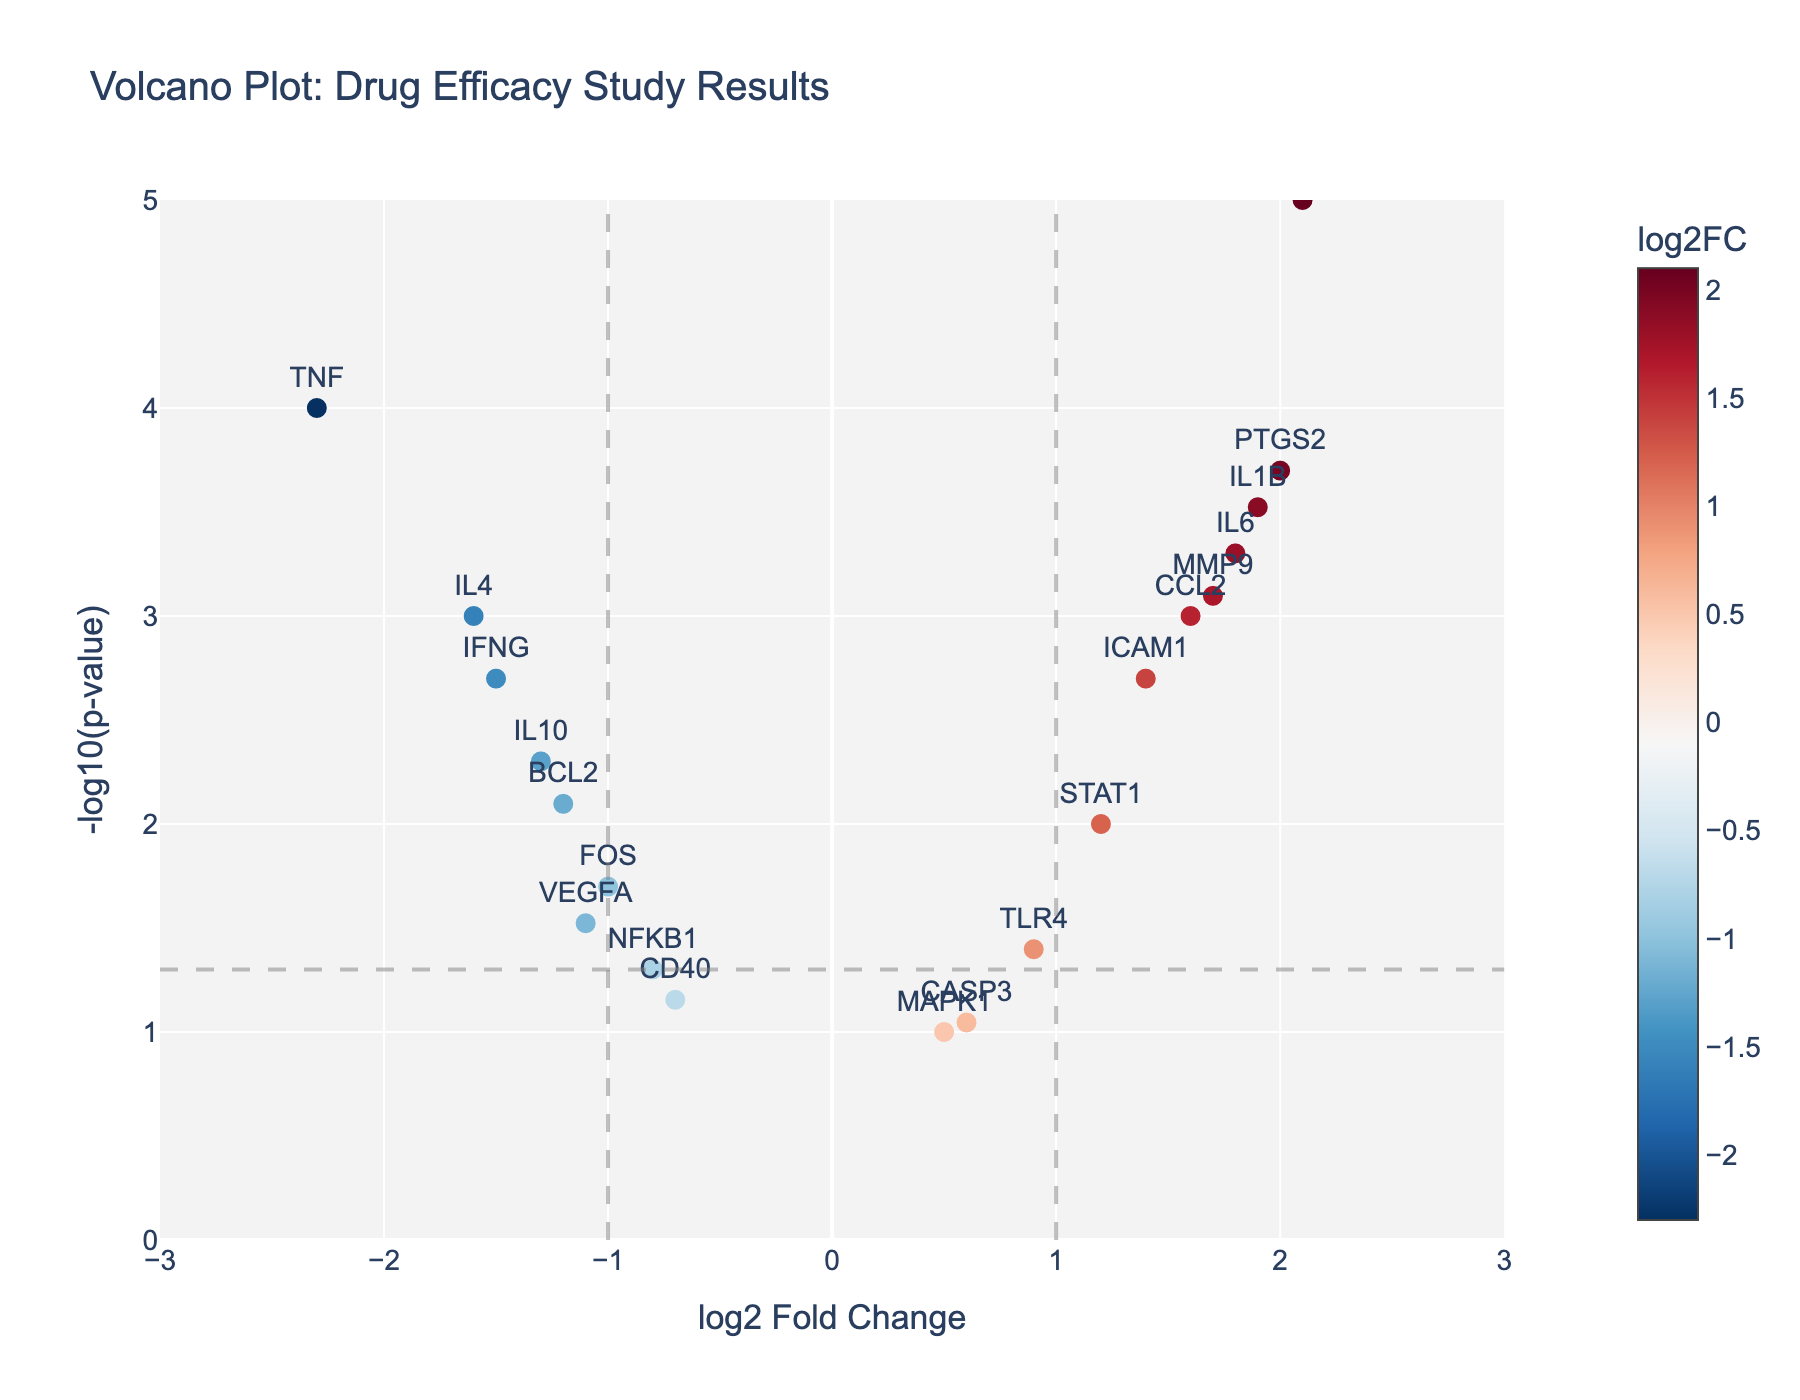How many data points are plotted in the figure? Count the number of marker points visible in the figure. There are 20 genes listed in the dataset, each corresponding to one marker.
Answer: 20 What does the horizontal dashed line represent? The horizontal dashed line represents a statistical significance threshold at a p-value of 0.05. Points above this line are considered statistically significant.
Answer: Statistical significance threshold Which gene has the highest -log10(p-value) and what is its value? Identify the gene with the highest y-axis value. CXCL10 has the highest -log10(p-value) because it has the lowest p-value (0.00001), giving a -log10(p-value) of 5.
Answer: CXCL10, 5 Which genes show a log2FoldChange greater than 1 and are statistically significant (p-value < 0.05)? Look at the points on the right side of the x-axis line (log2FoldChange > 1) that are also above the horizontal significance threshold line. The genes are IL6, CXCL10, IL1B, ICAM1, and PTGS2.
Answer: IL6, CXCL10, IL1B, ICAM1, PTGS2 Which genes show a log2FoldChange less than -1 and are statistically significant (p-value < 0.05)? Look at the points on the left side of the x-axis line (log2FoldChange < -1) that are also above the horizontal significance threshold line. The genes are TNF, IFNG, and IL4.
Answer: TNF, IFNG, IL4 What is the title of the figure? The title is displayed prominently at the top of the figure. It reads as "Volcano Plot: Drug Efficacy Study Results".
Answer: Volcano Plot: Drug Efficacy Study Results Compare the expression of TNF and IL6 in terms of log2FoldChange. Which one is upregulated and which one is downregulated? TNF has a log2FoldChange of -2.3, while IL6 has a log2FoldChange of 1.8. A negative log2FoldChange indicates downregulation (TNF) and a positive log2FoldChange indicates upregulation (IL6).
Answer: TNF: downregulated, IL6: upregulated What is the range of the x-axis and y-axis values in the figure? The x-axis range is from -3 to 3 (log2FoldChange) and the y-axis range is from 0 to 5 (-log10(p-value)).
Answer: x: -3 to 3, y: 0 to 5 Identify one of the genes that are not statistically significant (p-value >= 0.05) and state its log2FoldChange. Identify any points below the horizontal significance line. NFKB1 has a log2FoldChange of -0.8 and a p-value of 0.05.
Answer: NFKB1, -0.8 